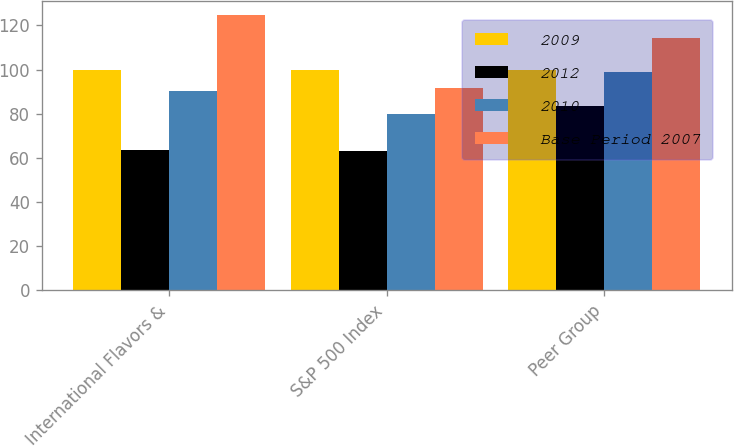Convert chart. <chart><loc_0><loc_0><loc_500><loc_500><stacked_bar_chart><ecel><fcel>International Flavors &<fcel>S&P 500 Index<fcel>Peer Group<nl><fcel>2009<fcel>100<fcel>100<fcel>100<nl><fcel>2012<fcel>63.36<fcel>63<fcel>83.68<nl><fcel>2010<fcel>90.24<fcel>79.67<fcel>98.92<nl><fcel>Base Period 2007<fcel>124.58<fcel>91.68<fcel>114.32<nl></chart> 